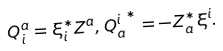<formula> <loc_0><loc_0><loc_500><loc_500>Q _ { i } ^ { a } = \xi _ { i } ^ { * } Z ^ { a } , { Q _ { a } ^ { i } } ^ { * } = - Z _ { a } ^ { * } \xi ^ { i } .</formula> 